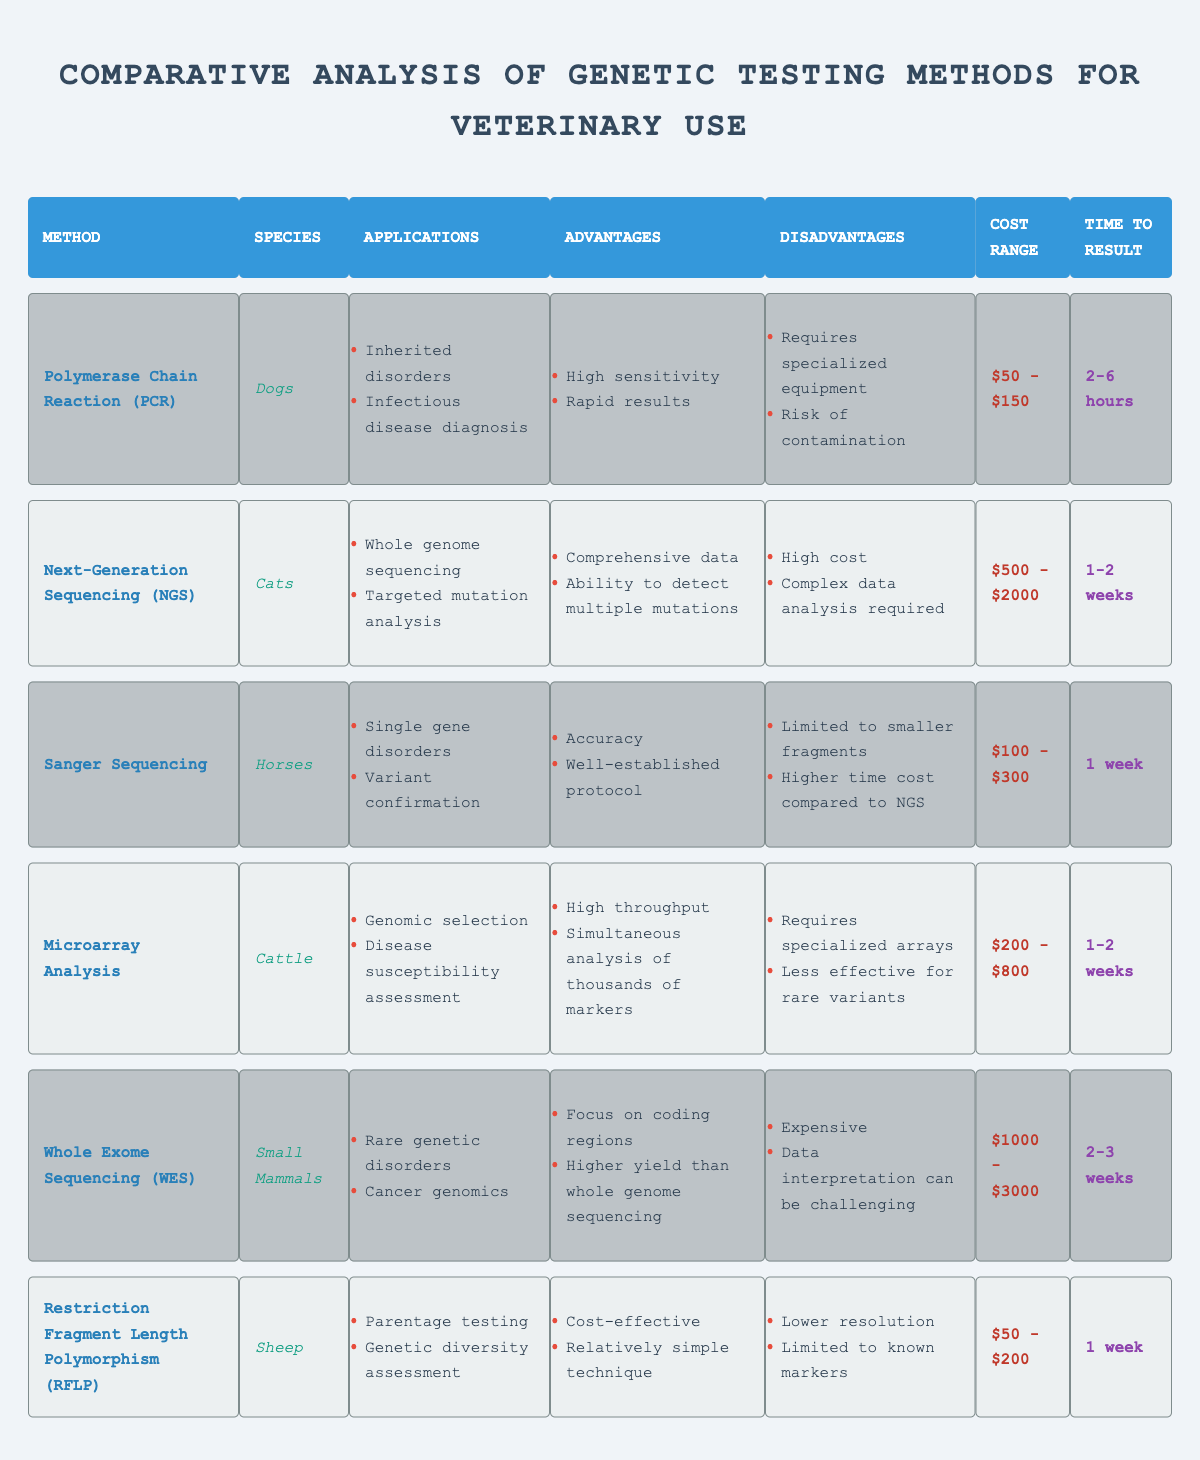What is the cost range for Polymerase Chain Reaction (PCR)? The cost range for PCR is directly stated in the table under the "Cost Range" column for that method. It shows $50 - $150.
Answer: $50 - $150 Which species is tested using Next-Generation Sequencing (NGS)? The species tested with NGS is found in the "Species" column corresponding to that method. The table indicates that NGS is used for Cats.
Answer: Cats How long does it take to get results from Sanger Sequencing? The time to result for Sanger Sequencing is listed in the "Time to Result" column for that method, which states 1 week.
Answer: 1 week What are the advantages of Microarray Analysis? To answer the question, we refer to the "Advantages" column for Microarray Analysis and find that it lists two advantages: high throughput and simultaneous analysis of thousands of markers.
Answer: High throughput; simultaneous analysis of thousands of markers Which genetic testing method has the highest cost range? To determine this, we look at the "Cost Range" column for each method and compare the values. Whole Exome Sequencing (WES) shows the highest range of $1000 - $3000.
Answer: Whole Exome Sequencing (WES) Does Restriction Fragment Length Polymorphism (RFLP) have a higher time to result than Polymerase Chain Reaction (PCR)? We need to check both the "Time to Result" for RFLP (1 week) and for PCR (2-6 hours). Since 1 week is longer than 6 hours (the upper limit for PCR), the answer is yes.
Answer: Yes What is the main application for Whole Exome Sequencing (WES)? The primary application is found in the "Applications" column for WES. It indicates it is used for rare genetic disorders and cancer genomics.
Answer: Rare genetic disorders; cancer genomics How does the time to result for Microarray Analysis compare to that of Next-Generation Sequencing (NGS)? We check the "Time to Result" for Microarray Analysis (1-2 weeks) and NGS (1-2 weeks). Since they both have the same time range, they are comparable.
Answer: They are comparable Which testing method requires specialized equipment? The "Disadvantages" column for PCR mentions that it requires specialized equipment. This is the only method in the data that specifically states this requirement.
Answer: Polymerase Chain Reaction (PCR) If you wanted to perform a parentage test, which method would you choose? The "Applications" column for Restriction Fragment Length Polymorphism (RFLP) directly states that one of its applications is parentage testing.
Answer: Restriction Fragment Length Polymorphism (RFLP) What is the average cost range of all genetic testing methods? To find the average, we first calculate the total cost ranges. Using the averages of ($100, $350, $1500, $500, $2000, $200) gives us a total of $4500, and dividing that by 6 methods results in an average of $750.
Answer: $750 